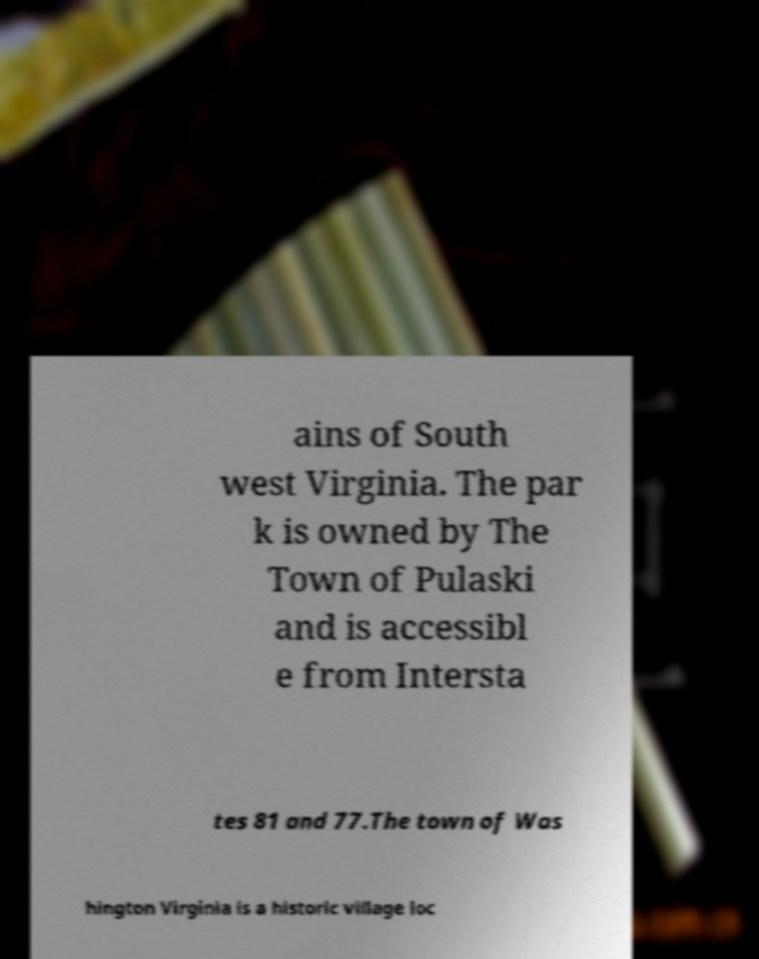I need the written content from this picture converted into text. Can you do that? ains of South west Virginia. The par k is owned by The Town of Pulaski and is accessibl e from Intersta tes 81 and 77.The town of Was hington Virginia is a historic village loc 